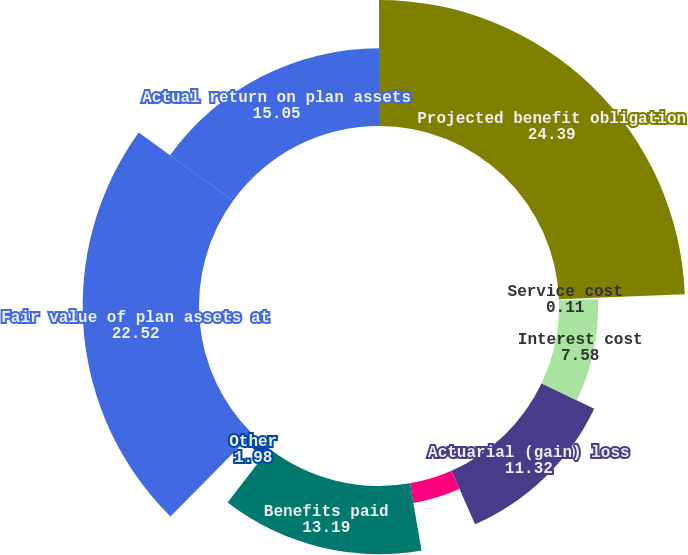<chart> <loc_0><loc_0><loc_500><loc_500><pie_chart><fcel>Projected benefit obligation<fcel>Service cost<fcel>Interest cost<fcel>Actuarial (gain) loss<fcel>Settlement/curtailment<fcel>Benefits paid<fcel>Other<fcel>Fair value of plan assets at<fcel>Actual return on plan assets<nl><fcel>24.39%<fcel>0.11%<fcel>7.58%<fcel>11.32%<fcel>3.85%<fcel>13.19%<fcel>1.98%<fcel>22.52%<fcel>15.05%<nl></chart> 